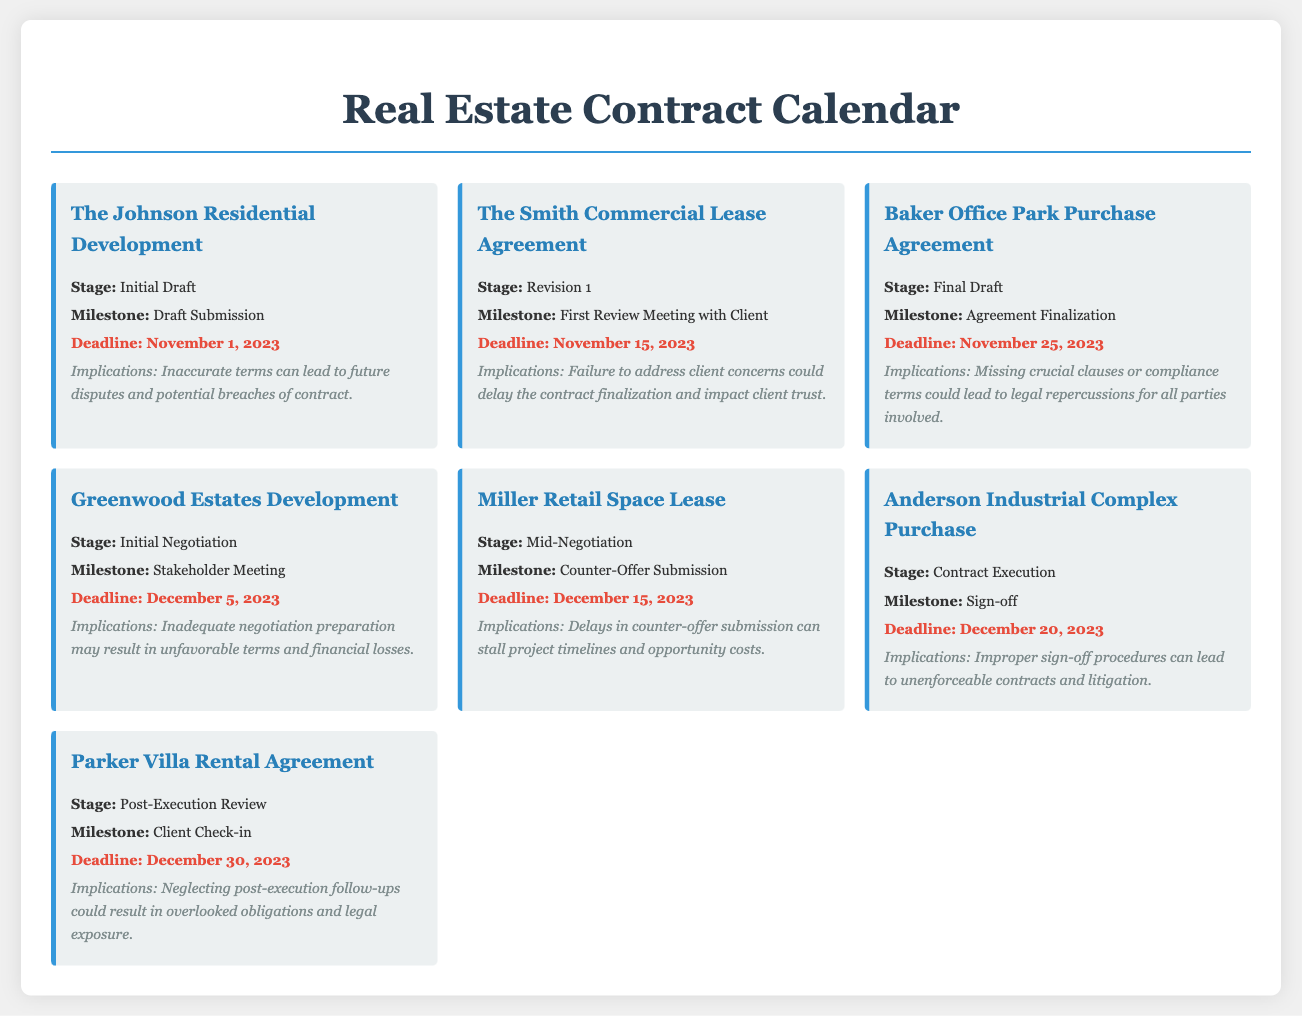What is the name of the project in the initial draft stage? The document lists "The Johnson Residential Development" as the project in the initial draft stage.
Answer: The Johnson Residential Development What is the deadline for the first review meeting with the client? The document specifies that the deadline for this milestone in "The Smith Commercial Lease Agreement" is November 15, 2023.
Answer: November 15, 2023 What implications are associated with the Baker Office Park Purchase Agreement? The document states that missing crucial clauses or compliance terms could lead to legal repercussions for all parties involved in this agreement.
Answer: Legal repercussions What stage is the Miller Retail Space Lease currently in? According to the document, the Miller Retail Space Lease is in the mid-negotiation stage.
Answer: Mid-Negotiation How many days left until the deadline for the Greenwood Estates Development stakeholder meeting? The deadline is December 5, 2023, and today's date is November 1, 2023; thus, there are 34 days left.
Answer: 34 days What is a potential consequence of neglecting post-execution follow-ups? The document outlines that neglecting these follow-ups could result in overlooked obligations and legal exposure.
Answer: Legal exposure Which project is set for contract execution by December 20, 2023? The document indicates that the Anderson Industrial Complex Purchase is scheduled for contract execution on this date.
Answer: Anderson Industrial Complex Purchase What milestone is associated with the purchase agreement for Baker Office Park? The milestone listed for this agreement is agreement finalization.
Answer: Agreement Finalization 